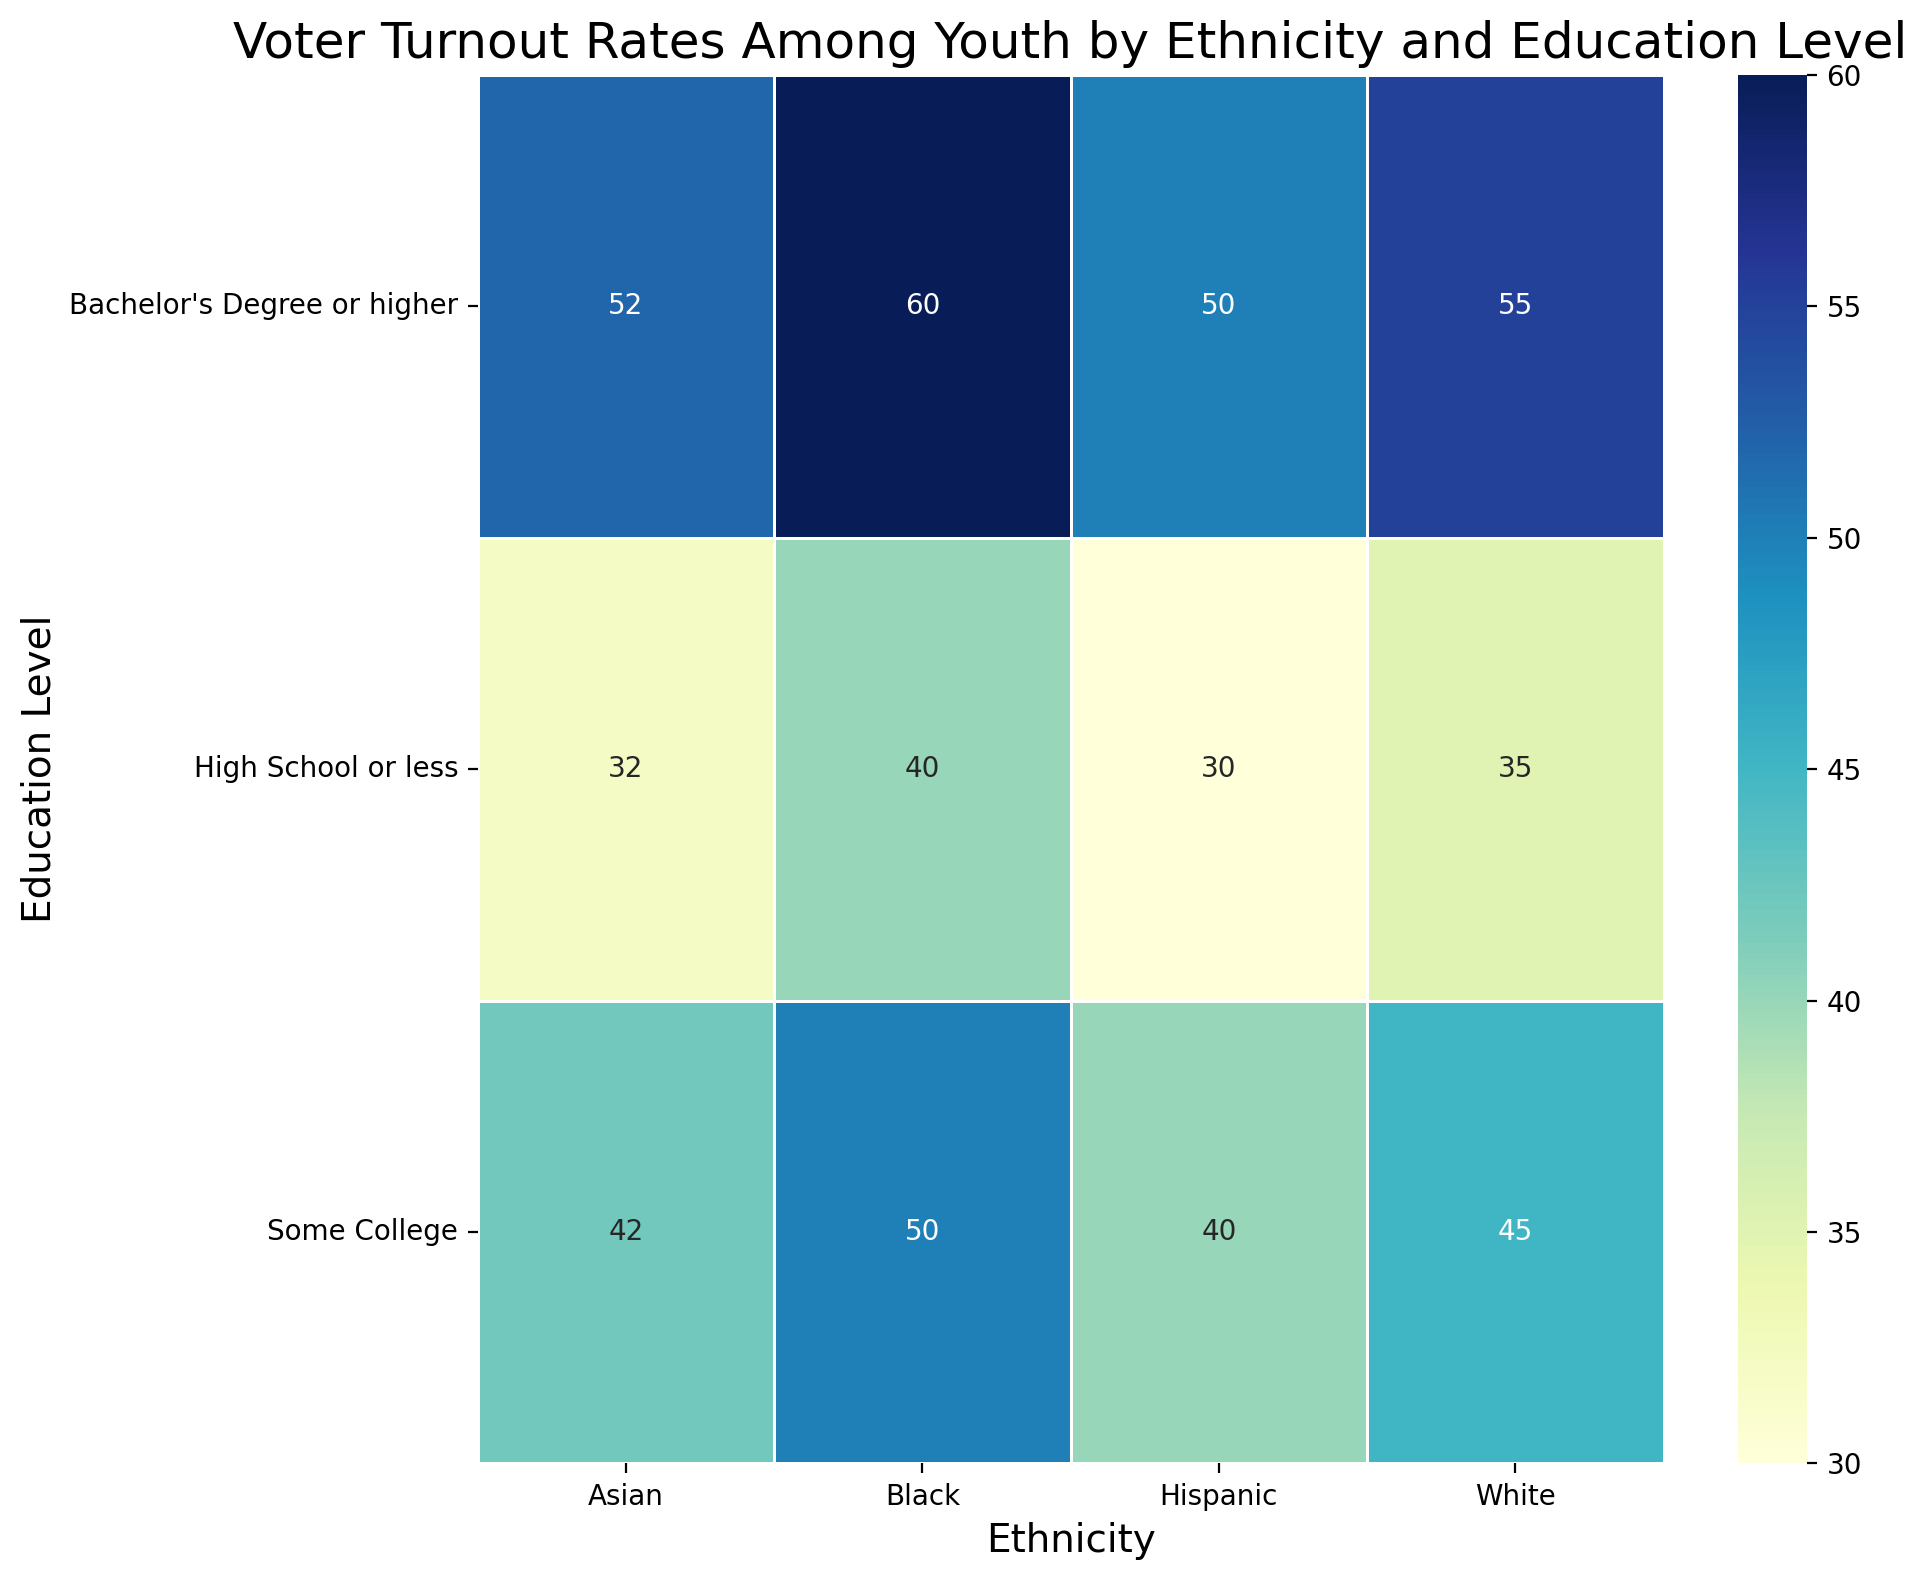What is the voter turnout rate for Hispanic youth with a Bachelor's Degree or higher? Look at the cell where the "Hispanic" column intersects with the "Bachelor's Degree or higher" row, which shows a rate of 50.
Answer: 50 How does the voter turnout rate for Black youth with a high school education or less compare to that of White youth with the same education level? Find the cells corresponding to "High School or less" for both "Black" and "White". Black youth have a rate of 40 while White youth have a rate of 35.
Answer: Black youth have a higher turnout rate What's the difference in voter turnout rate between Asian youth with some college education and Hispanic youth with a Bachelor's Degree or higher? Subtract the voter turnout rate for Hispanic youth with a Bachelor's Degree or higher (50) from the rate for Asian youth with some college education (42). 42 - 50 = -8
Answer: -8 Which ethnic group has the highest voter turnout rate among youth with a high school education or less? Identify the values in the "High School or less" row and determine the highest numerical value. Black youth have the highest rate at 40.
Answer: Black What is the average voter turnout rate across all education levels for White youth? Sum the turnout rates for White youth (35 + 45 + 55) and divide by 3. (35 + 45 + 55) / 3 = 45
Answer: 45 Compare the voter turnout rates for youth with some college across different ethnicities. Which group has the lowest rate? Look at the "Some College" row and identify the lowest value, which is 40 for Hispanic youth.
Answer: Hispanic What is the combined voter turnout rate for Hispanic and Black youth with a Bachelor's Degree or higher? Add the turnout rates for both groups at the "Bachelor's Degree or higher" level. 50 (Hispanic) + 60 (Black) = 110
Answer: 110 Which ethnic group has the smallest increase in voter turnout rate when moving from "Some College" to "Bachelor's Degree or higher"? Calculate the increase for each ethnicity and determine the smallest: White (55-45=10), Black (60-50=10), Hispanic (50-40=10), Asian (52-42=10). All groups have the same increase of 10.
Answer: All groups have the same increase What is the difference in voter turnout rates between the highest and lowest values for the "Some College" education level? Look at the "Some College" row and identify the highest value (50 for Black) and the lowest value (40 for Hispanic). 50 - 40 = 10
Answer: 10 Which cell shows the highest voter turnout rate in the heatmap? Identify the cell with the highest numerical value in the entire heatmap, which is 60 for Black youth with a Bachelor's Degree or higher.
Answer: 60 